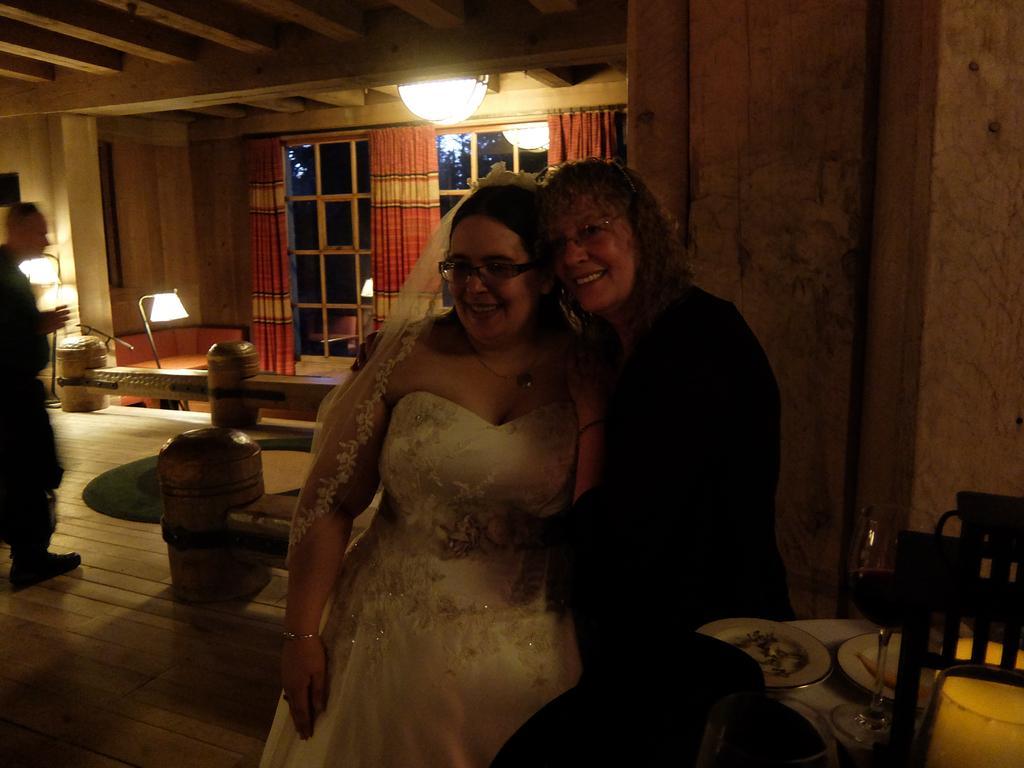In one or two sentences, can you explain what this image depicts? In the image we can see there are two women who are standing and the room is little dark. 